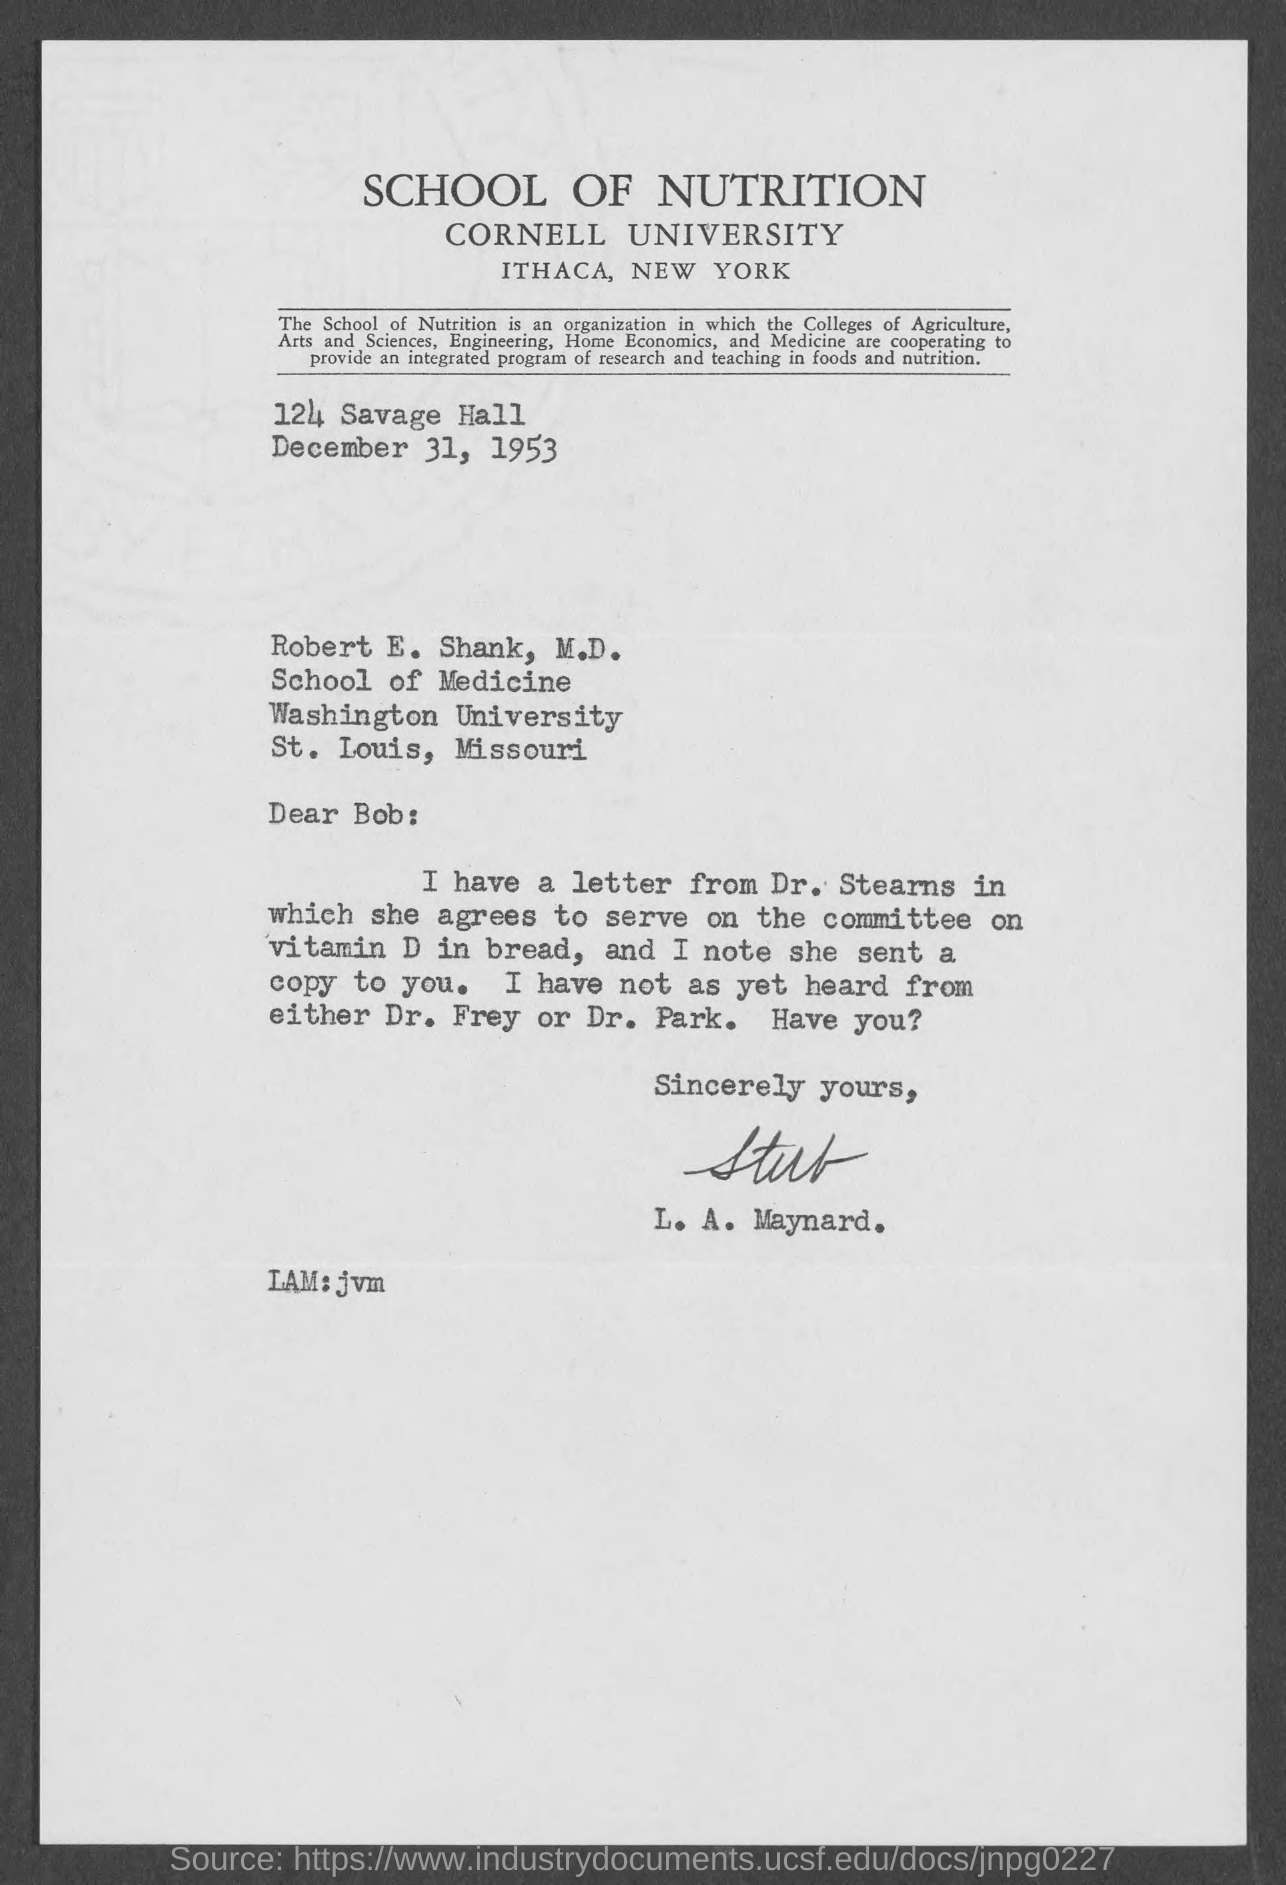When is the Memorandum dated on ?
Keep it short and to the point. December 31, 1953. 